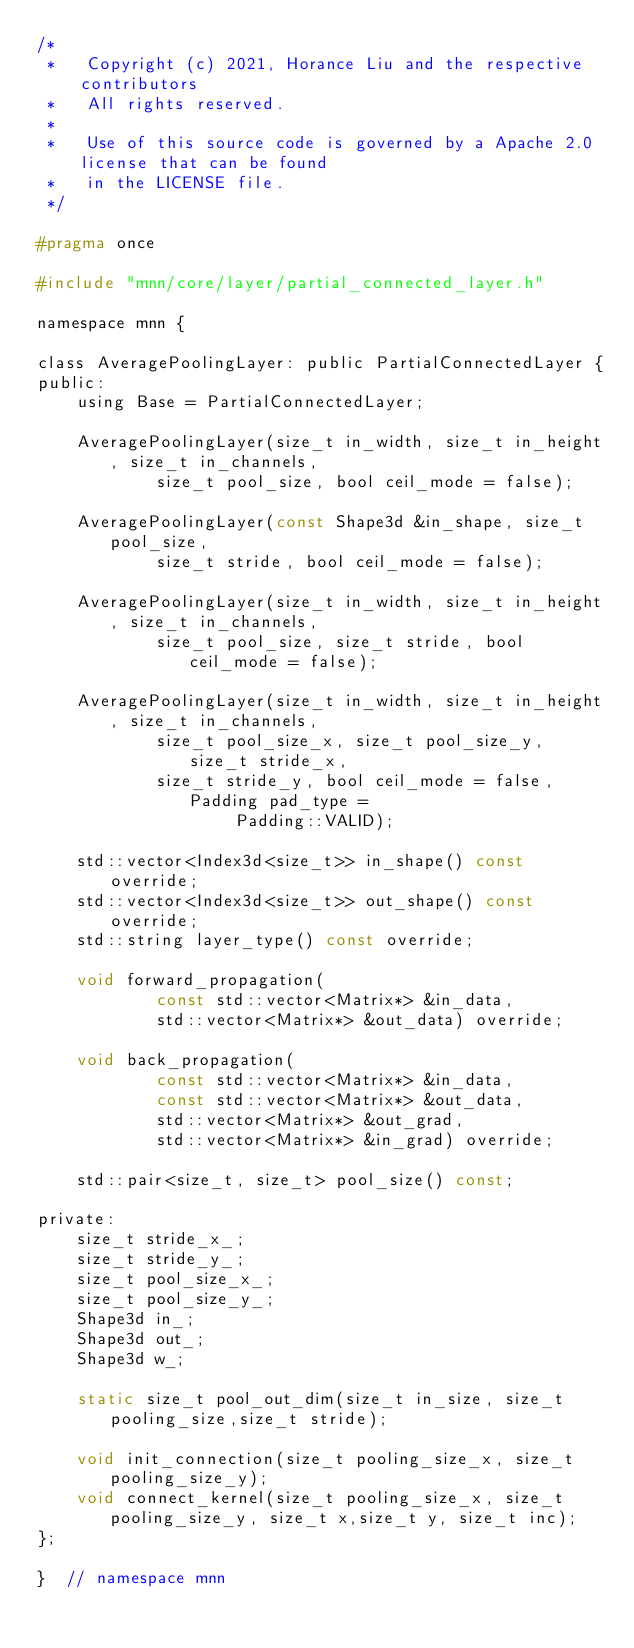<code> <loc_0><loc_0><loc_500><loc_500><_C_>/*
 *   Copyright (c) 2021, Horance Liu and the respective contributors
 *   All rights reserved.
 *
 *   Use of this source code is governed by a Apache 2.0 license that can be found
 *   in the LICENSE file.
 */

#pragma once

#include "mnn/core/layer/partial_connected_layer.h"

namespace mnn {

class AveragePoolingLayer: public PartialConnectedLayer {
public:
    using Base = PartialConnectedLayer;

    AveragePoolingLayer(size_t in_width, size_t in_height, size_t in_channels,
            size_t pool_size, bool ceil_mode = false);

    AveragePoolingLayer(const Shape3d &in_shape, size_t pool_size,
            size_t stride, bool ceil_mode = false);

    AveragePoolingLayer(size_t in_width, size_t in_height, size_t in_channels,
            size_t pool_size, size_t stride, bool ceil_mode = false);

    AveragePoolingLayer(size_t in_width, size_t in_height, size_t in_channels,
            size_t pool_size_x, size_t pool_size_y, size_t stride_x,
            size_t stride_y, bool ceil_mode = false, Padding pad_type =
                    Padding::VALID);

    std::vector<Index3d<size_t>> in_shape() const override;
    std::vector<Index3d<size_t>> out_shape() const override;
    std::string layer_type() const override;

    void forward_propagation(
            const std::vector<Matrix*> &in_data,
            std::vector<Matrix*> &out_data) override;

    void back_propagation(
            const std::vector<Matrix*> &in_data,
            const std::vector<Matrix*> &out_data,
            std::vector<Matrix*> &out_grad,
            std::vector<Matrix*> &in_grad) override;

    std::pair<size_t, size_t> pool_size() const;

private:
    size_t stride_x_;
    size_t stride_y_;
    size_t pool_size_x_;
    size_t pool_size_y_;
    Shape3d in_;
    Shape3d out_;
    Shape3d w_;

    static size_t pool_out_dim(size_t in_size, size_t pooling_size,size_t stride);

    void init_connection(size_t pooling_size_x, size_t pooling_size_y);
    void connect_kernel(size_t pooling_size_x, size_t pooling_size_y, size_t x,size_t y, size_t inc);
};

}  // namespace mnn
</code> 